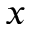Convert formula to latex. <formula><loc_0><loc_0><loc_500><loc_500>x</formula> 